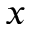Convert formula to latex. <formula><loc_0><loc_0><loc_500><loc_500>x</formula> 